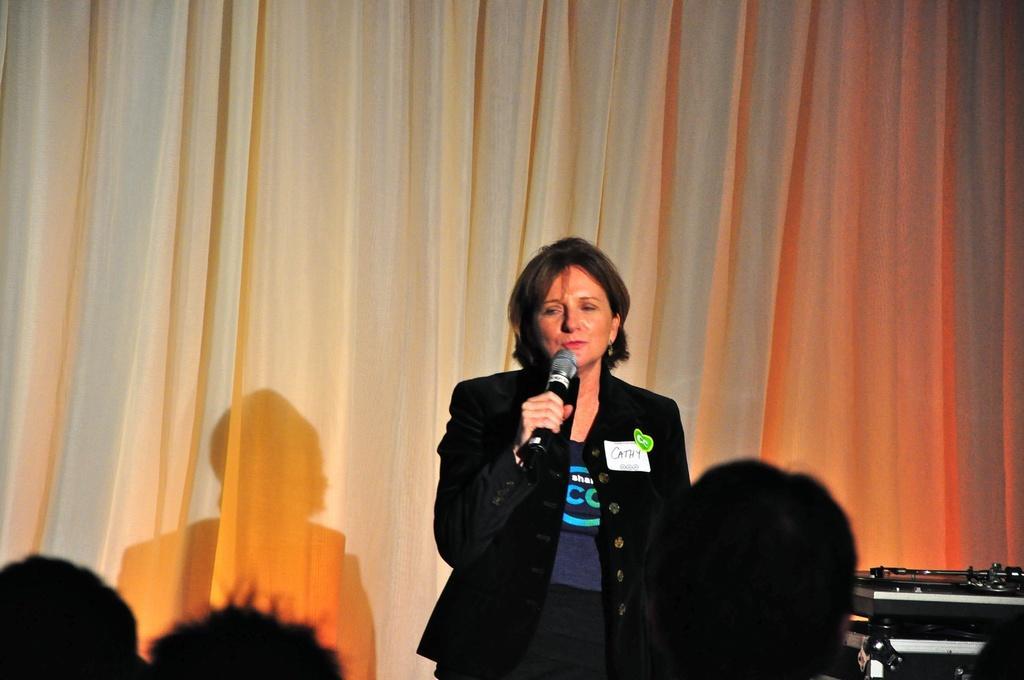Can you describe this image briefly? A woman wearing a black coat holding a mic. Behind her there is a curtain. Some head of a person are visible. 